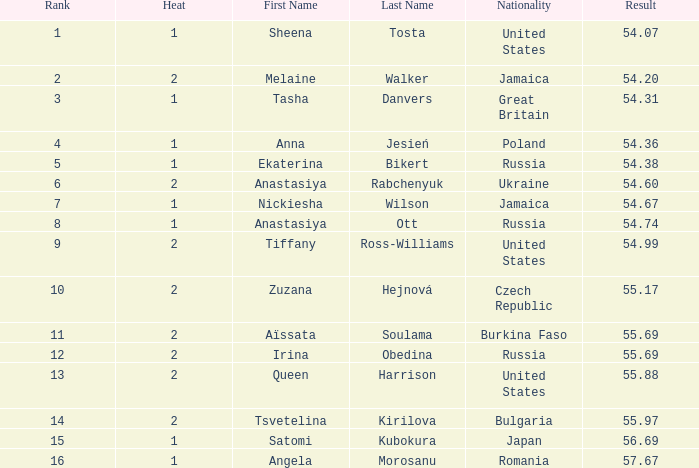Which Heat has a Nationality of bulgaria, and a Result larger than 55.97? None. 